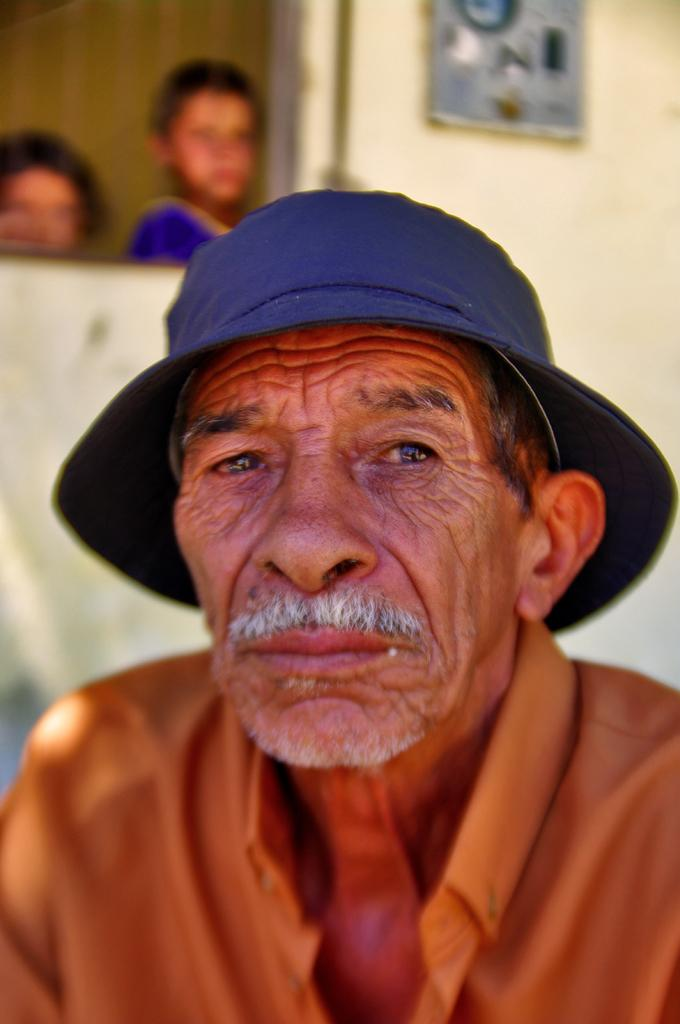Who is the main subject in the image? There is a man in the center of the image. What is the man wearing on his head? The man is wearing a hat. What can be seen in the background of the image? There are kids and an object on the wall in the background. What type of mask is the man wearing in the image? The man is not wearing a mask in the image; he is wearing a hat. 